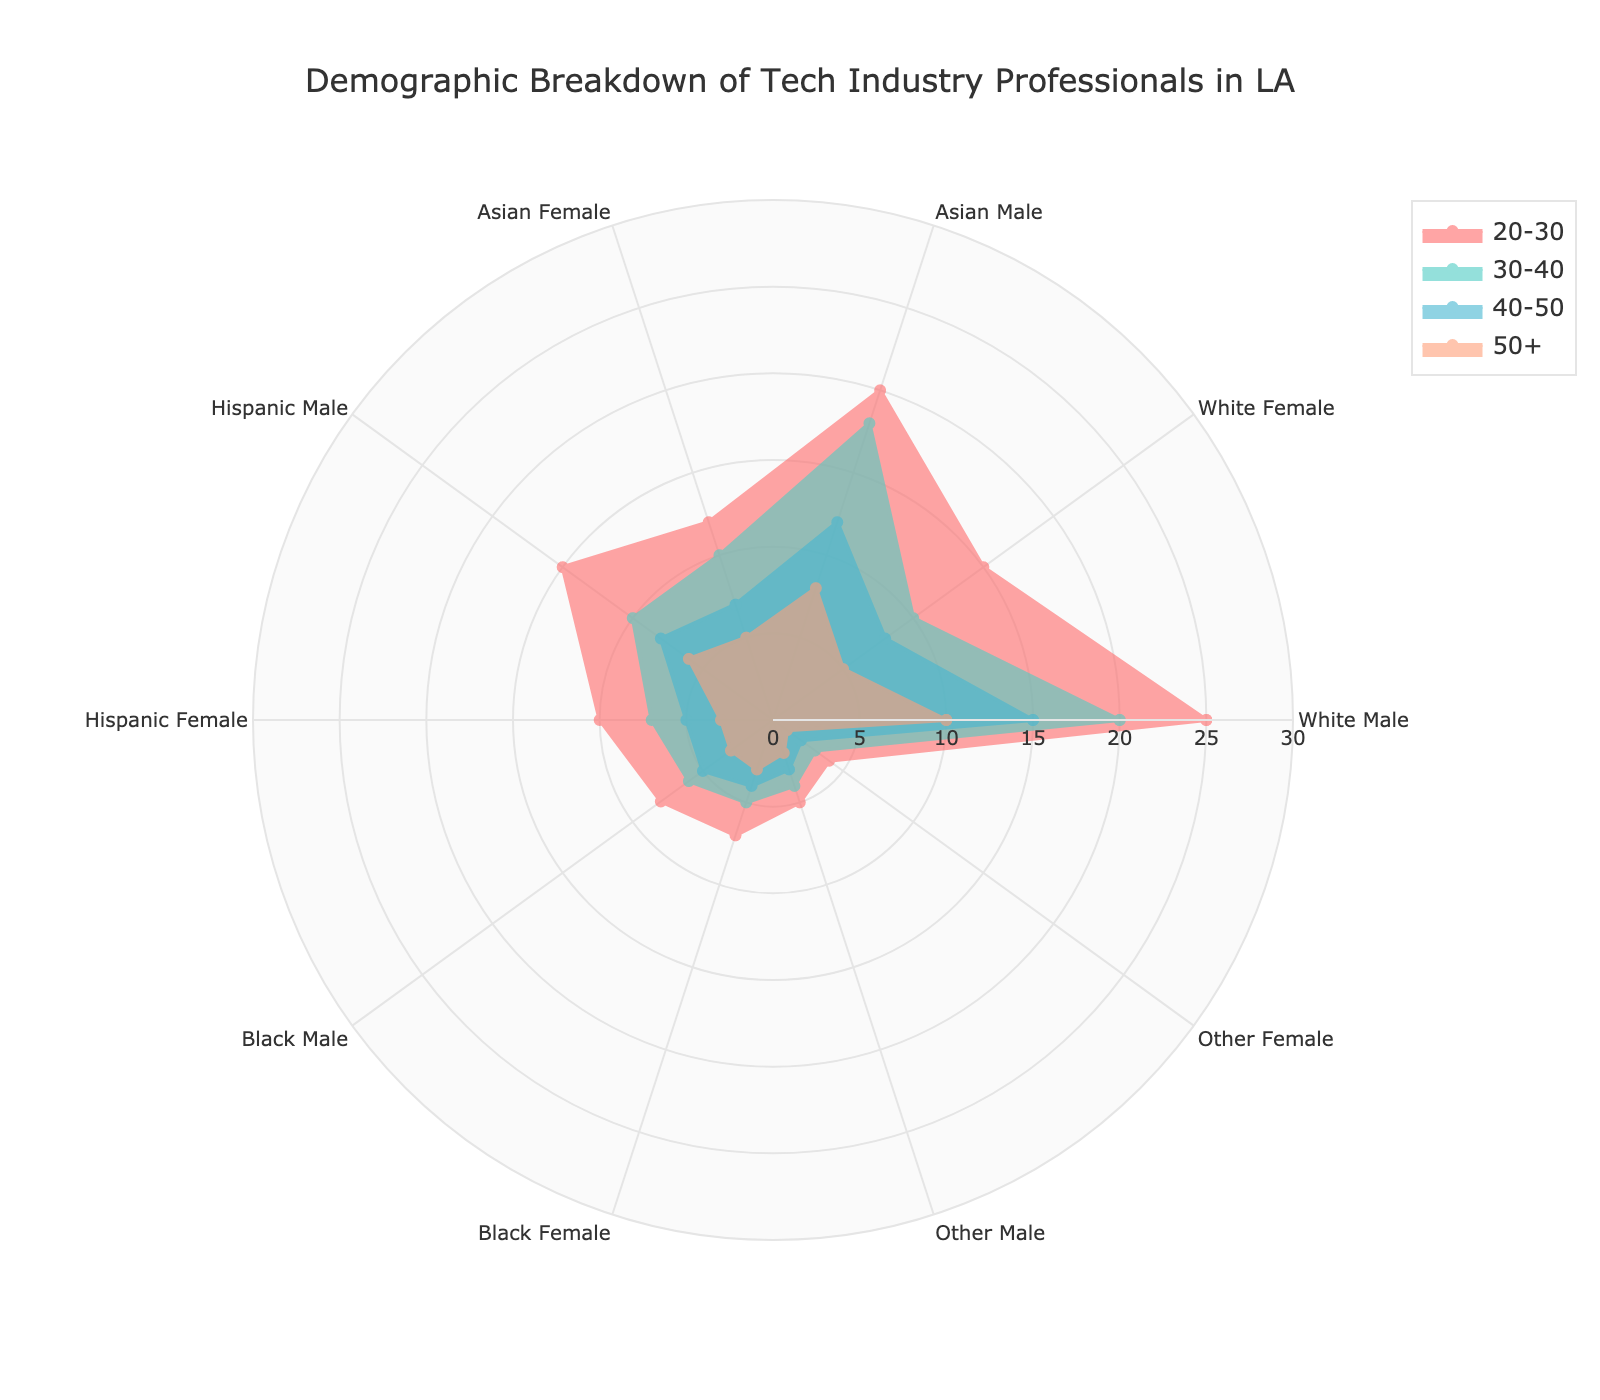What's the title of the radar chart? The title is usually displayed prominently at the top of the figure, indicating what data the chart is representing. Observing the radar plot title will give you an idea of the context and data being visualized.
Answer: Demographic Breakdown of Tech Industry Professionals in LA How many age groups are represented in the chart? The age groups are distinct sections of the data, typically shown as categories or axes on the radar chart. Counting these will give you the total number of age categories being compared.
Answer: Four Which age group has the highest representation for White Males? By observing the axis corresponding to White Males, you can see the values for each age group and identify the highest one.
Answer: 20-30 What is the total number of Black Females in the 20-30 and 30-40 age groups? Add the values of Black Females in the 20-30 and 30-40 age groups from the radar chart. Step-by-Step: Locate the Black Female category, find the values for the given age groups, and sum them up. Black Female (20-30) = 7, Black Female (30-40) = 5. Thus, total = 7 + 5.
Answer: 12 Compare the representation of Asian Males and Asian Females in the 40-50 age group. Which one is higher? View the values for the 40-50 age group under both Asian Males and Asian Females, then compare the two numbers directly.
Answer: Asian Males Which ethnic and gender group has the lowest representation in the 50+ age group? To find the lowest value in the 50+ age group, observe the values across all categories for this specific age group and identify the smallest number.
Answer: Other Female On which axis is the range for the radial values, and what is its maximum value? The radial axis is the one that dictates the extent of the values around the radar chart. Examining the axis labels and notations helps determine the range and maximum value.
Answer: Radial axis, 30 Which age group appears to have the most balanced representation across all demographic categories? By observing the radar chart lines for each age group, identify the group whose values are more evenly spread out or balanced. This requires assessing the values visually to see which age group has the least variation among the different demographics.
Answer: 50+ What's the representation difference between Hispanic Males and Hispanic Females in the 30-40 age group? Subtract the 30-40 age group value for Hispanic Females from that of Hispanic Males. Step-by-Step: Locate values for both Hispanic Males (30-40) = 10 and Hispanic Females (30-40) = 7; compute 10 - 7.
Answer: 3 